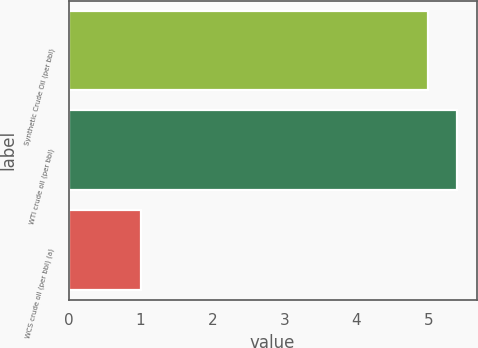Convert chart. <chart><loc_0><loc_0><loc_500><loc_500><bar_chart><fcel>Synthetic Crude Oil (per bbl)<fcel>WTI crude oil (per bbl)<fcel>WCS crude oil (per bbl) (a)<nl><fcel>5<fcel>5.4<fcel>1<nl></chart> 